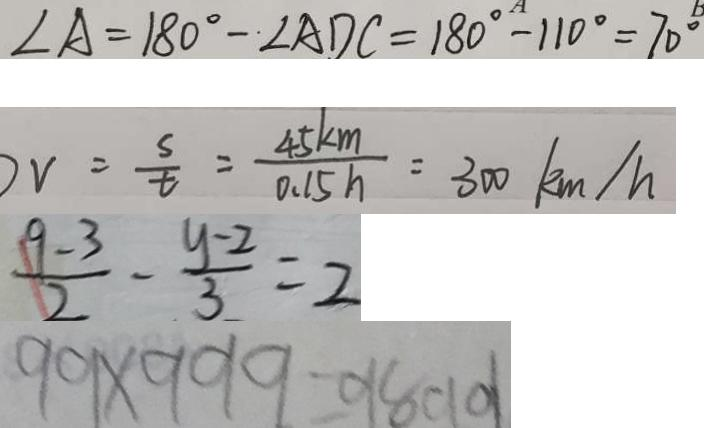<formula> <loc_0><loc_0><loc_500><loc_500>\angle A = 1 8 0 ^ { \circ } - \angle A D C = 1 8 0 ^ { \circ } - 1 1 0 ^ { \circ } = 7 0 ^ { \circ } 
 v = \frac { s } { t } = \frac { 4 5 k m } { 0 . 1 5 h } = 3 0 0 k m / h 
 \frac { 9 - 3 } { 2 } - \frac { y - 2 } { 3 } = 2 
 9 9 \times 9 9 9 = 9 8 0 1 0 1</formula> 